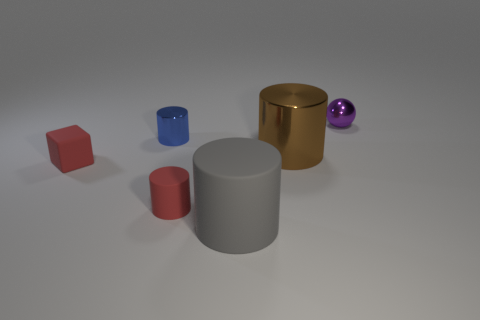Are there any other things that are the same shape as the blue object?
Make the answer very short. Yes. Do the purple thing and the tiny cylinder that is in front of the blue metallic object have the same material?
Your answer should be compact. No. What number of blue things are either rubber cubes or tiny metal cylinders?
Ensure brevity in your answer.  1. Is there a brown cylinder?
Give a very brief answer. Yes. There is a tiny shiny thing that is in front of the tiny metallic object that is on the right side of the tiny red cylinder; is there a shiny object to the right of it?
Your answer should be compact. Yes. Is there anything else that has the same size as the rubber cube?
Keep it short and to the point. Yes. There is a large matte object; is its shape the same as the red rubber object that is to the right of the tiny shiny cylinder?
Offer a very short reply. Yes. There is a metallic cylinder that is on the right side of the matte thing in front of the tiny red thing that is right of the blue object; what is its color?
Make the answer very short. Brown. How many objects are either objects in front of the purple sphere or cylinders right of the blue cylinder?
Provide a succinct answer. 5. How many other objects are there of the same color as the matte cube?
Your answer should be very brief. 1. 